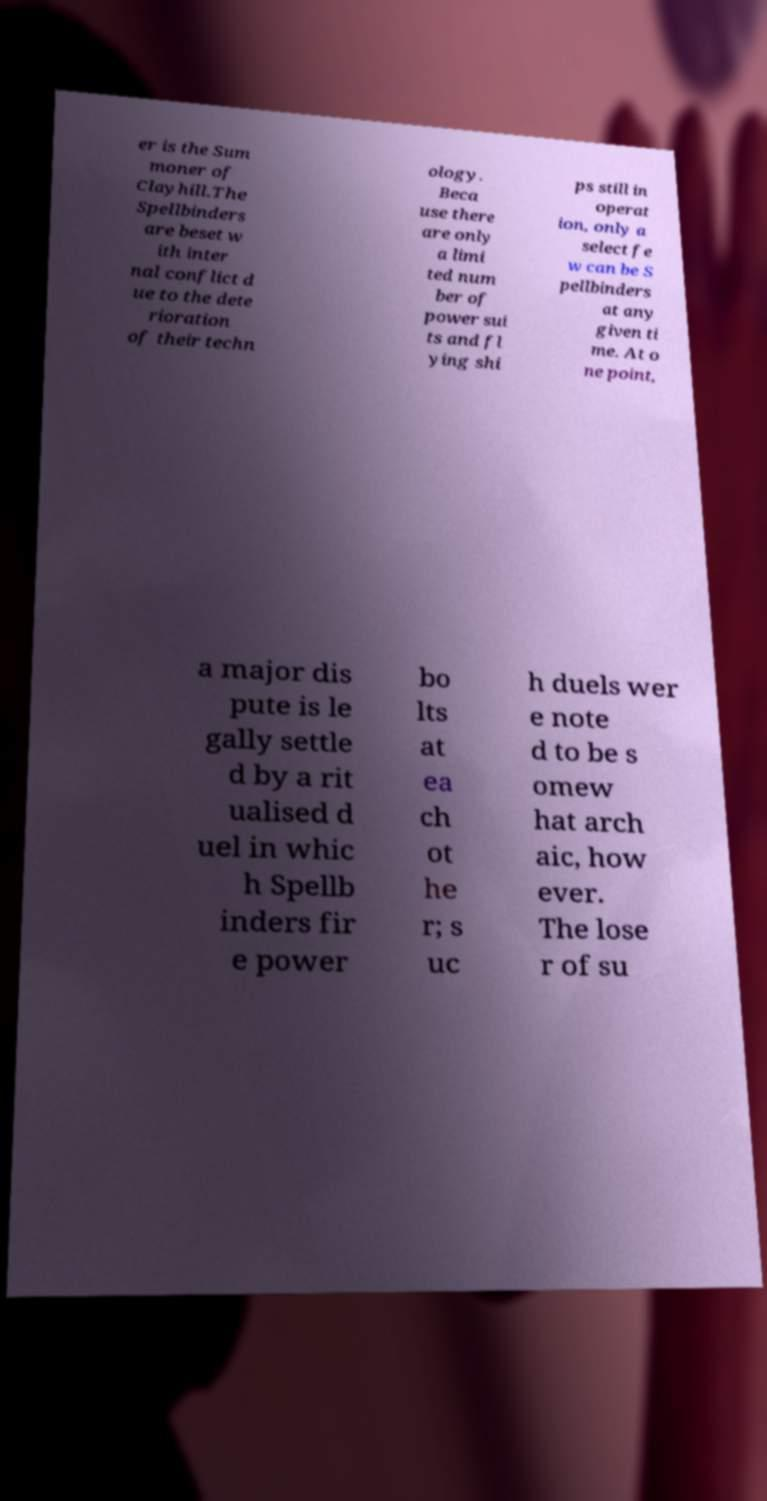Please identify and transcribe the text found in this image. er is the Sum moner of Clayhill.The Spellbinders are beset w ith inter nal conflict d ue to the dete rioration of their techn ology. Beca use there are only a limi ted num ber of power sui ts and fl ying shi ps still in operat ion, only a select fe w can be S pellbinders at any given ti me. At o ne point, a major dis pute is le gally settle d by a rit ualised d uel in whic h Spellb inders fir e power bo lts at ea ch ot he r; s uc h duels wer e note d to be s omew hat arch aic, how ever. The lose r of su 